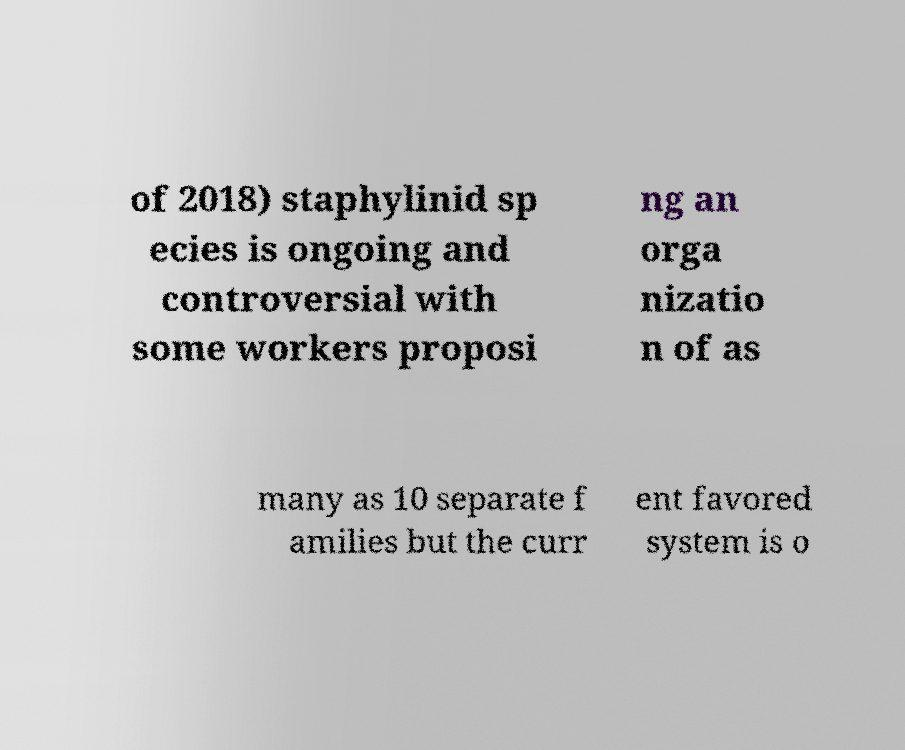Could you assist in decoding the text presented in this image and type it out clearly? of 2018) staphylinid sp ecies is ongoing and controversial with some workers proposi ng an orga nizatio n of as many as 10 separate f amilies but the curr ent favored system is o 